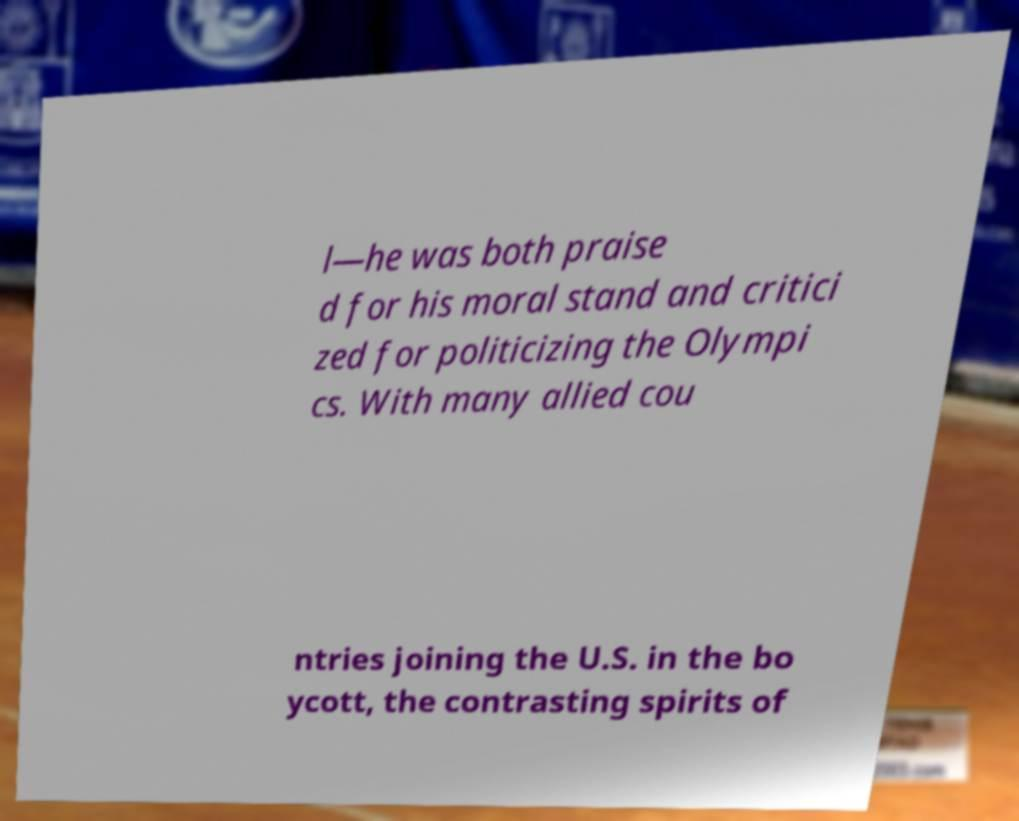Can you read and provide the text displayed in the image?This photo seems to have some interesting text. Can you extract and type it out for me? l—he was both praise d for his moral stand and critici zed for politicizing the Olympi cs. With many allied cou ntries joining the U.S. in the bo ycott, the contrasting spirits of 